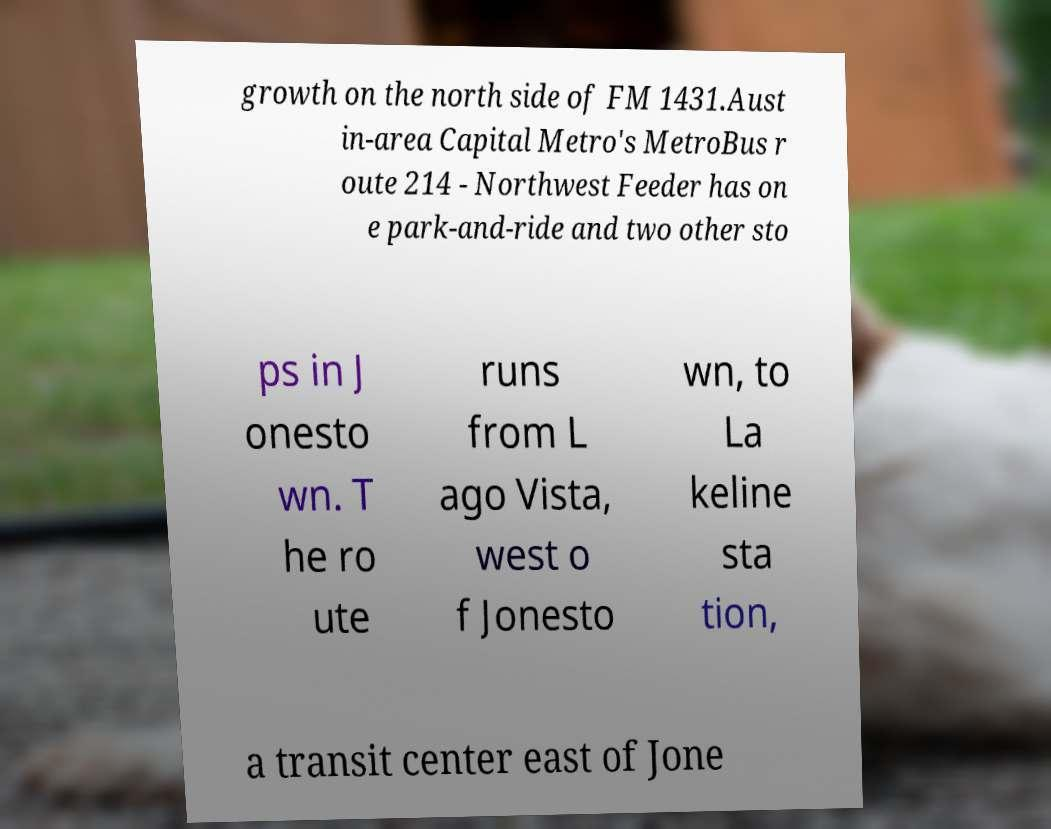I need the written content from this picture converted into text. Can you do that? growth on the north side of FM 1431.Aust in-area Capital Metro's MetroBus r oute 214 - Northwest Feeder has on e park-and-ride and two other sto ps in J onesto wn. T he ro ute runs from L ago Vista, west o f Jonesto wn, to La keline sta tion, a transit center east of Jone 